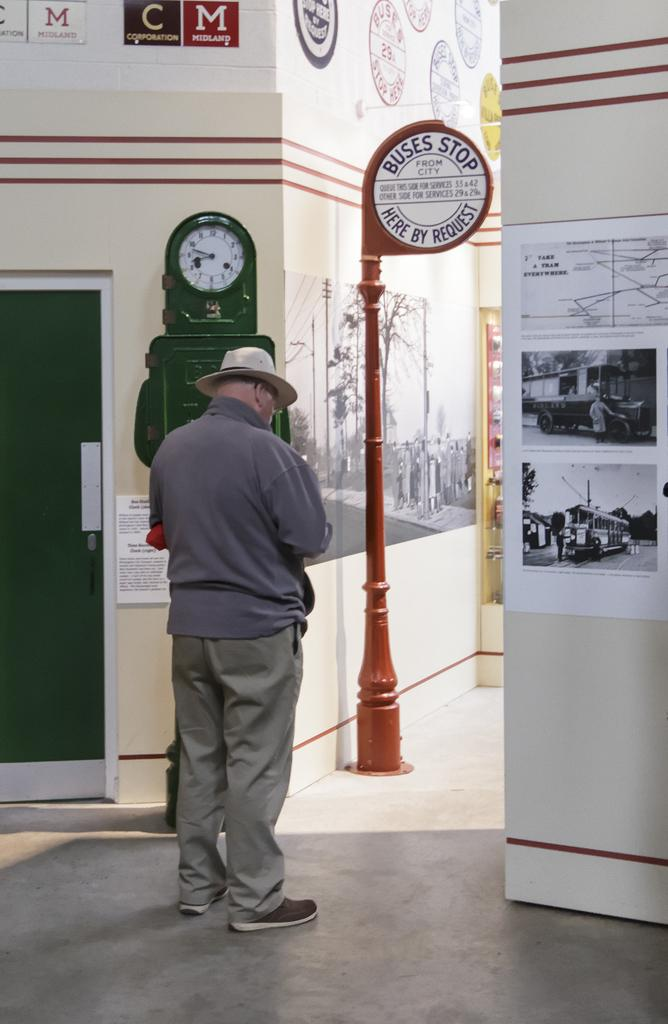<image>
Offer a succinct explanation of the picture presented. A man is standing near a red sign saying Buses stop here by request 